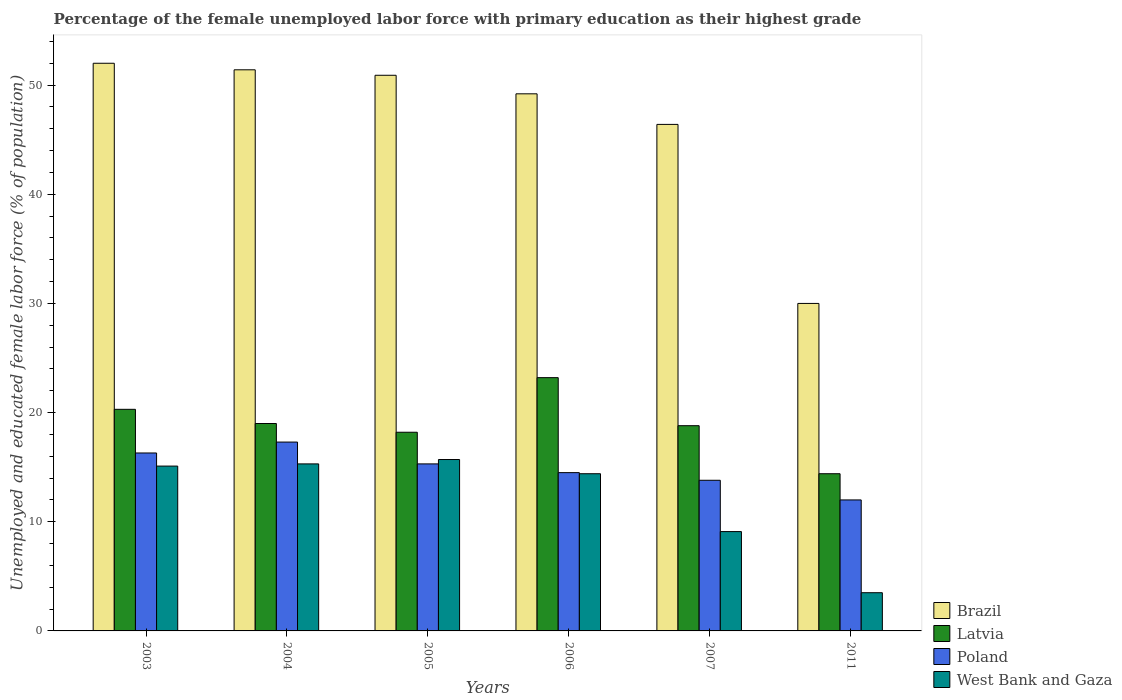How many different coloured bars are there?
Ensure brevity in your answer.  4. How many groups of bars are there?
Offer a very short reply. 6. What is the percentage of the unemployed female labor force with primary education in Latvia in 2004?
Your response must be concise. 19. Across all years, what is the maximum percentage of the unemployed female labor force with primary education in Latvia?
Ensure brevity in your answer.  23.2. What is the total percentage of the unemployed female labor force with primary education in West Bank and Gaza in the graph?
Offer a very short reply. 73.1. What is the difference between the percentage of the unemployed female labor force with primary education in Latvia in 2003 and the percentage of the unemployed female labor force with primary education in Brazil in 2004?
Give a very brief answer. -31.1. What is the average percentage of the unemployed female labor force with primary education in West Bank and Gaza per year?
Provide a succinct answer. 12.18. What is the ratio of the percentage of the unemployed female labor force with primary education in Poland in 2004 to that in 2007?
Your answer should be compact. 1.25. Is the percentage of the unemployed female labor force with primary education in Latvia in 2003 less than that in 2005?
Your response must be concise. No. What is the difference between the highest and the second highest percentage of the unemployed female labor force with primary education in West Bank and Gaza?
Give a very brief answer. 0.4. What is the difference between the highest and the lowest percentage of the unemployed female labor force with primary education in Latvia?
Your answer should be compact. 8.8. In how many years, is the percentage of the unemployed female labor force with primary education in West Bank and Gaza greater than the average percentage of the unemployed female labor force with primary education in West Bank and Gaza taken over all years?
Keep it short and to the point. 4. Is it the case that in every year, the sum of the percentage of the unemployed female labor force with primary education in Latvia and percentage of the unemployed female labor force with primary education in Poland is greater than the sum of percentage of the unemployed female labor force with primary education in West Bank and Gaza and percentage of the unemployed female labor force with primary education in Brazil?
Keep it short and to the point. No. What does the 1st bar from the right in 2004 represents?
Make the answer very short. West Bank and Gaza. How many bars are there?
Make the answer very short. 24. How many years are there in the graph?
Give a very brief answer. 6. What is the difference between two consecutive major ticks on the Y-axis?
Offer a very short reply. 10. Where does the legend appear in the graph?
Give a very brief answer. Bottom right. How are the legend labels stacked?
Provide a short and direct response. Vertical. What is the title of the graph?
Offer a terse response. Percentage of the female unemployed labor force with primary education as their highest grade. Does "Sint Maarten (Dutch part)" appear as one of the legend labels in the graph?
Your answer should be compact. No. What is the label or title of the Y-axis?
Ensure brevity in your answer.  Unemployed and educated female labor force (% of population). What is the Unemployed and educated female labor force (% of population) of Brazil in 2003?
Offer a very short reply. 52. What is the Unemployed and educated female labor force (% of population) in Latvia in 2003?
Give a very brief answer. 20.3. What is the Unemployed and educated female labor force (% of population) of Poland in 2003?
Offer a terse response. 16.3. What is the Unemployed and educated female labor force (% of population) in West Bank and Gaza in 2003?
Offer a very short reply. 15.1. What is the Unemployed and educated female labor force (% of population) in Brazil in 2004?
Provide a short and direct response. 51.4. What is the Unemployed and educated female labor force (% of population) of Poland in 2004?
Give a very brief answer. 17.3. What is the Unemployed and educated female labor force (% of population) in West Bank and Gaza in 2004?
Make the answer very short. 15.3. What is the Unemployed and educated female labor force (% of population) in Brazil in 2005?
Provide a succinct answer. 50.9. What is the Unemployed and educated female labor force (% of population) of Latvia in 2005?
Give a very brief answer. 18.2. What is the Unemployed and educated female labor force (% of population) of Poland in 2005?
Offer a terse response. 15.3. What is the Unemployed and educated female labor force (% of population) of West Bank and Gaza in 2005?
Your answer should be compact. 15.7. What is the Unemployed and educated female labor force (% of population) of Brazil in 2006?
Your response must be concise. 49.2. What is the Unemployed and educated female labor force (% of population) in Latvia in 2006?
Provide a succinct answer. 23.2. What is the Unemployed and educated female labor force (% of population) in West Bank and Gaza in 2006?
Offer a terse response. 14.4. What is the Unemployed and educated female labor force (% of population) in Brazil in 2007?
Provide a short and direct response. 46.4. What is the Unemployed and educated female labor force (% of population) of Latvia in 2007?
Make the answer very short. 18.8. What is the Unemployed and educated female labor force (% of population) of Poland in 2007?
Offer a very short reply. 13.8. What is the Unemployed and educated female labor force (% of population) of West Bank and Gaza in 2007?
Ensure brevity in your answer.  9.1. What is the Unemployed and educated female labor force (% of population) in Brazil in 2011?
Your answer should be very brief. 30. What is the Unemployed and educated female labor force (% of population) in Latvia in 2011?
Give a very brief answer. 14.4. What is the Unemployed and educated female labor force (% of population) in Poland in 2011?
Provide a short and direct response. 12. Across all years, what is the maximum Unemployed and educated female labor force (% of population) of Brazil?
Make the answer very short. 52. Across all years, what is the maximum Unemployed and educated female labor force (% of population) of Latvia?
Your response must be concise. 23.2. Across all years, what is the maximum Unemployed and educated female labor force (% of population) in Poland?
Ensure brevity in your answer.  17.3. Across all years, what is the maximum Unemployed and educated female labor force (% of population) in West Bank and Gaza?
Give a very brief answer. 15.7. Across all years, what is the minimum Unemployed and educated female labor force (% of population) of Brazil?
Offer a terse response. 30. Across all years, what is the minimum Unemployed and educated female labor force (% of population) of Latvia?
Provide a short and direct response. 14.4. What is the total Unemployed and educated female labor force (% of population) of Brazil in the graph?
Offer a terse response. 279.9. What is the total Unemployed and educated female labor force (% of population) in Latvia in the graph?
Make the answer very short. 113.9. What is the total Unemployed and educated female labor force (% of population) of Poland in the graph?
Offer a very short reply. 89.2. What is the total Unemployed and educated female labor force (% of population) of West Bank and Gaza in the graph?
Provide a short and direct response. 73.1. What is the difference between the Unemployed and educated female labor force (% of population) in Brazil in 2003 and that in 2004?
Your answer should be very brief. 0.6. What is the difference between the Unemployed and educated female labor force (% of population) of Brazil in 2003 and that in 2005?
Your response must be concise. 1.1. What is the difference between the Unemployed and educated female labor force (% of population) of Brazil in 2003 and that in 2006?
Provide a short and direct response. 2.8. What is the difference between the Unemployed and educated female labor force (% of population) in Poland in 2003 and that in 2007?
Offer a very short reply. 2.5. What is the difference between the Unemployed and educated female labor force (% of population) of Brazil in 2003 and that in 2011?
Give a very brief answer. 22. What is the difference between the Unemployed and educated female labor force (% of population) in Poland in 2003 and that in 2011?
Ensure brevity in your answer.  4.3. What is the difference between the Unemployed and educated female labor force (% of population) in Brazil in 2004 and that in 2005?
Provide a succinct answer. 0.5. What is the difference between the Unemployed and educated female labor force (% of population) in Latvia in 2004 and that in 2005?
Your answer should be very brief. 0.8. What is the difference between the Unemployed and educated female labor force (% of population) of Latvia in 2004 and that in 2006?
Your response must be concise. -4.2. What is the difference between the Unemployed and educated female labor force (% of population) of Poland in 2004 and that in 2006?
Provide a succinct answer. 2.8. What is the difference between the Unemployed and educated female labor force (% of population) of West Bank and Gaza in 2004 and that in 2006?
Your answer should be very brief. 0.9. What is the difference between the Unemployed and educated female labor force (% of population) in Brazil in 2004 and that in 2007?
Provide a short and direct response. 5. What is the difference between the Unemployed and educated female labor force (% of population) in Poland in 2004 and that in 2007?
Give a very brief answer. 3.5. What is the difference between the Unemployed and educated female labor force (% of population) of West Bank and Gaza in 2004 and that in 2007?
Give a very brief answer. 6.2. What is the difference between the Unemployed and educated female labor force (% of population) in Brazil in 2004 and that in 2011?
Ensure brevity in your answer.  21.4. What is the difference between the Unemployed and educated female labor force (% of population) of Latvia in 2004 and that in 2011?
Your answer should be compact. 4.6. What is the difference between the Unemployed and educated female labor force (% of population) of Poland in 2004 and that in 2011?
Make the answer very short. 5.3. What is the difference between the Unemployed and educated female labor force (% of population) of West Bank and Gaza in 2004 and that in 2011?
Ensure brevity in your answer.  11.8. What is the difference between the Unemployed and educated female labor force (% of population) of Poland in 2005 and that in 2006?
Provide a succinct answer. 0.8. What is the difference between the Unemployed and educated female labor force (% of population) of Latvia in 2005 and that in 2007?
Your answer should be very brief. -0.6. What is the difference between the Unemployed and educated female labor force (% of population) of Brazil in 2005 and that in 2011?
Your response must be concise. 20.9. What is the difference between the Unemployed and educated female labor force (% of population) in West Bank and Gaza in 2005 and that in 2011?
Provide a short and direct response. 12.2. What is the difference between the Unemployed and educated female labor force (% of population) of Brazil in 2006 and that in 2007?
Offer a very short reply. 2.8. What is the difference between the Unemployed and educated female labor force (% of population) of West Bank and Gaza in 2006 and that in 2007?
Provide a short and direct response. 5.3. What is the difference between the Unemployed and educated female labor force (% of population) of Poland in 2006 and that in 2011?
Offer a very short reply. 2.5. What is the difference between the Unemployed and educated female labor force (% of population) of Latvia in 2007 and that in 2011?
Provide a short and direct response. 4.4. What is the difference between the Unemployed and educated female labor force (% of population) of Poland in 2007 and that in 2011?
Provide a short and direct response. 1.8. What is the difference between the Unemployed and educated female labor force (% of population) in Brazil in 2003 and the Unemployed and educated female labor force (% of population) in Poland in 2004?
Your answer should be compact. 34.7. What is the difference between the Unemployed and educated female labor force (% of population) in Brazil in 2003 and the Unemployed and educated female labor force (% of population) in West Bank and Gaza in 2004?
Give a very brief answer. 36.7. What is the difference between the Unemployed and educated female labor force (% of population) of Latvia in 2003 and the Unemployed and educated female labor force (% of population) of Poland in 2004?
Provide a short and direct response. 3. What is the difference between the Unemployed and educated female labor force (% of population) of Latvia in 2003 and the Unemployed and educated female labor force (% of population) of West Bank and Gaza in 2004?
Give a very brief answer. 5. What is the difference between the Unemployed and educated female labor force (% of population) in Brazil in 2003 and the Unemployed and educated female labor force (% of population) in Latvia in 2005?
Give a very brief answer. 33.8. What is the difference between the Unemployed and educated female labor force (% of population) of Brazil in 2003 and the Unemployed and educated female labor force (% of population) of Poland in 2005?
Keep it short and to the point. 36.7. What is the difference between the Unemployed and educated female labor force (% of population) of Brazil in 2003 and the Unemployed and educated female labor force (% of population) of West Bank and Gaza in 2005?
Your answer should be very brief. 36.3. What is the difference between the Unemployed and educated female labor force (% of population) of Brazil in 2003 and the Unemployed and educated female labor force (% of population) of Latvia in 2006?
Provide a short and direct response. 28.8. What is the difference between the Unemployed and educated female labor force (% of population) in Brazil in 2003 and the Unemployed and educated female labor force (% of population) in Poland in 2006?
Your answer should be compact. 37.5. What is the difference between the Unemployed and educated female labor force (% of population) of Brazil in 2003 and the Unemployed and educated female labor force (% of population) of West Bank and Gaza in 2006?
Your answer should be very brief. 37.6. What is the difference between the Unemployed and educated female labor force (% of population) of Latvia in 2003 and the Unemployed and educated female labor force (% of population) of West Bank and Gaza in 2006?
Provide a succinct answer. 5.9. What is the difference between the Unemployed and educated female labor force (% of population) of Poland in 2003 and the Unemployed and educated female labor force (% of population) of West Bank and Gaza in 2006?
Offer a very short reply. 1.9. What is the difference between the Unemployed and educated female labor force (% of population) in Brazil in 2003 and the Unemployed and educated female labor force (% of population) in Latvia in 2007?
Give a very brief answer. 33.2. What is the difference between the Unemployed and educated female labor force (% of population) of Brazil in 2003 and the Unemployed and educated female labor force (% of population) of Poland in 2007?
Your answer should be very brief. 38.2. What is the difference between the Unemployed and educated female labor force (% of population) of Brazil in 2003 and the Unemployed and educated female labor force (% of population) of West Bank and Gaza in 2007?
Your answer should be compact. 42.9. What is the difference between the Unemployed and educated female labor force (% of population) of Latvia in 2003 and the Unemployed and educated female labor force (% of population) of Poland in 2007?
Your answer should be compact. 6.5. What is the difference between the Unemployed and educated female labor force (% of population) of Poland in 2003 and the Unemployed and educated female labor force (% of population) of West Bank and Gaza in 2007?
Offer a very short reply. 7.2. What is the difference between the Unemployed and educated female labor force (% of population) of Brazil in 2003 and the Unemployed and educated female labor force (% of population) of Latvia in 2011?
Your answer should be very brief. 37.6. What is the difference between the Unemployed and educated female labor force (% of population) of Brazil in 2003 and the Unemployed and educated female labor force (% of population) of West Bank and Gaza in 2011?
Keep it short and to the point. 48.5. What is the difference between the Unemployed and educated female labor force (% of population) in Latvia in 2003 and the Unemployed and educated female labor force (% of population) in West Bank and Gaza in 2011?
Provide a succinct answer. 16.8. What is the difference between the Unemployed and educated female labor force (% of population) of Poland in 2003 and the Unemployed and educated female labor force (% of population) of West Bank and Gaza in 2011?
Your answer should be compact. 12.8. What is the difference between the Unemployed and educated female labor force (% of population) in Brazil in 2004 and the Unemployed and educated female labor force (% of population) in Latvia in 2005?
Keep it short and to the point. 33.2. What is the difference between the Unemployed and educated female labor force (% of population) of Brazil in 2004 and the Unemployed and educated female labor force (% of population) of Poland in 2005?
Ensure brevity in your answer.  36.1. What is the difference between the Unemployed and educated female labor force (% of population) in Brazil in 2004 and the Unemployed and educated female labor force (% of population) in West Bank and Gaza in 2005?
Give a very brief answer. 35.7. What is the difference between the Unemployed and educated female labor force (% of population) in Latvia in 2004 and the Unemployed and educated female labor force (% of population) in Poland in 2005?
Provide a succinct answer. 3.7. What is the difference between the Unemployed and educated female labor force (% of population) of Poland in 2004 and the Unemployed and educated female labor force (% of population) of West Bank and Gaza in 2005?
Keep it short and to the point. 1.6. What is the difference between the Unemployed and educated female labor force (% of population) of Brazil in 2004 and the Unemployed and educated female labor force (% of population) of Latvia in 2006?
Keep it short and to the point. 28.2. What is the difference between the Unemployed and educated female labor force (% of population) in Brazil in 2004 and the Unemployed and educated female labor force (% of population) in Poland in 2006?
Ensure brevity in your answer.  36.9. What is the difference between the Unemployed and educated female labor force (% of population) in Brazil in 2004 and the Unemployed and educated female labor force (% of population) in West Bank and Gaza in 2006?
Your answer should be compact. 37. What is the difference between the Unemployed and educated female labor force (% of population) of Latvia in 2004 and the Unemployed and educated female labor force (% of population) of Poland in 2006?
Your answer should be very brief. 4.5. What is the difference between the Unemployed and educated female labor force (% of population) in Brazil in 2004 and the Unemployed and educated female labor force (% of population) in Latvia in 2007?
Give a very brief answer. 32.6. What is the difference between the Unemployed and educated female labor force (% of population) of Brazil in 2004 and the Unemployed and educated female labor force (% of population) of Poland in 2007?
Your answer should be compact. 37.6. What is the difference between the Unemployed and educated female labor force (% of population) of Brazil in 2004 and the Unemployed and educated female labor force (% of population) of West Bank and Gaza in 2007?
Keep it short and to the point. 42.3. What is the difference between the Unemployed and educated female labor force (% of population) in Latvia in 2004 and the Unemployed and educated female labor force (% of population) in Poland in 2007?
Keep it short and to the point. 5.2. What is the difference between the Unemployed and educated female labor force (% of population) in Poland in 2004 and the Unemployed and educated female labor force (% of population) in West Bank and Gaza in 2007?
Your answer should be very brief. 8.2. What is the difference between the Unemployed and educated female labor force (% of population) in Brazil in 2004 and the Unemployed and educated female labor force (% of population) in Poland in 2011?
Keep it short and to the point. 39.4. What is the difference between the Unemployed and educated female labor force (% of population) of Brazil in 2004 and the Unemployed and educated female labor force (% of population) of West Bank and Gaza in 2011?
Ensure brevity in your answer.  47.9. What is the difference between the Unemployed and educated female labor force (% of population) in Latvia in 2004 and the Unemployed and educated female labor force (% of population) in Poland in 2011?
Provide a short and direct response. 7. What is the difference between the Unemployed and educated female labor force (% of population) in Poland in 2004 and the Unemployed and educated female labor force (% of population) in West Bank and Gaza in 2011?
Ensure brevity in your answer.  13.8. What is the difference between the Unemployed and educated female labor force (% of population) of Brazil in 2005 and the Unemployed and educated female labor force (% of population) of Latvia in 2006?
Your answer should be compact. 27.7. What is the difference between the Unemployed and educated female labor force (% of population) of Brazil in 2005 and the Unemployed and educated female labor force (% of population) of Poland in 2006?
Your answer should be compact. 36.4. What is the difference between the Unemployed and educated female labor force (% of population) of Brazil in 2005 and the Unemployed and educated female labor force (% of population) of West Bank and Gaza in 2006?
Your answer should be compact. 36.5. What is the difference between the Unemployed and educated female labor force (% of population) of Latvia in 2005 and the Unemployed and educated female labor force (% of population) of Poland in 2006?
Offer a very short reply. 3.7. What is the difference between the Unemployed and educated female labor force (% of population) of Poland in 2005 and the Unemployed and educated female labor force (% of population) of West Bank and Gaza in 2006?
Keep it short and to the point. 0.9. What is the difference between the Unemployed and educated female labor force (% of population) in Brazil in 2005 and the Unemployed and educated female labor force (% of population) in Latvia in 2007?
Offer a terse response. 32.1. What is the difference between the Unemployed and educated female labor force (% of population) of Brazil in 2005 and the Unemployed and educated female labor force (% of population) of Poland in 2007?
Your answer should be compact. 37.1. What is the difference between the Unemployed and educated female labor force (% of population) of Brazil in 2005 and the Unemployed and educated female labor force (% of population) of West Bank and Gaza in 2007?
Give a very brief answer. 41.8. What is the difference between the Unemployed and educated female labor force (% of population) of Latvia in 2005 and the Unemployed and educated female labor force (% of population) of Poland in 2007?
Your answer should be compact. 4.4. What is the difference between the Unemployed and educated female labor force (% of population) in Poland in 2005 and the Unemployed and educated female labor force (% of population) in West Bank and Gaza in 2007?
Your answer should be very brief. 6.2. What is the difference between the Unemployed and educated female labor force (% of population) of Brazil in 2005 and the Unemployed and educated female labor force (% of population) of Latvia in 2011?
Make the answer very short. 36.5. What is the difference between the Unemployed and educated female labor force (% of population) of Brazil in 2005 and the Unemployed and educated female labor force (% of population) of Poland in 2011?
Provide a succinct answer. 38.9. What is the difference between the Unemployed and educated female labor force (% of population) in Brazil in 2005 and the Unemployed and educated female labor force (% of population) in West Bank and Gaza in 2011?
Ensure brevity in your answer.  47.4. What is the difference between the Unemployed and educated female labor force (% of population) of Latvia in 2005 and the Unemployed and educated female labor force (% of population) of Poland in 2011?
Your answer should be very brief. 6.2. What is the difference between the Unemployed and educated female labor force (% of population) of Latvia in 2005 and the Unemployed and educated female labor force (% of population) of West Bank and Gaza in 2011?
Provide a short and direct response. 14.7. What is the difference between the Unemployed and educated female labor force (% of population) in Brazil in 2006 and the Unemployed and educated female labor force (% of population) in Latvia in 2007?
Your response must be concise. 30.4. What is the difference between the Unemployed and educated female labor force (% of population) in Brazil in 2006 and the Unemployed and educated female labor force (% of population) in Poland in 2007?
Provide a succinct answer. 35.4. What is the difference between the Unemployed and educated female labor force (% of population) in Brazil in 2006 and the Unemployed and educated female labor force (% of population) in West Bank and Gaza in 2007?
Your answer should be compact. 40.1. What is the difference between the Unemployed and educated female labor force (% of population) in Latvia in 2006 and the Unemployed and educated female labor force (% of population) in Poland in 2007?
Provide a short and direct response. 9.4. What is the difference between the Unemployed and educated female labor force (% of population) in Brazil in 2006 and the Unemployed and educated female labor force (% of population) in Latvia in 2011?
Keep it short and to the point. 34.8. What is the difference between the Unemployed and educated female labor force (% of population) of Brazil in 2006 and the Unemployed and educated female labor force (% of population) of Poland in 2011?
Provide a succinct answer. 37.2. What is the difference between the Unemployed and educated female labor force (% of population) of Brazil in 2006 and the Unemployed and educated female labor force (% of population) of West Bank and Gaza in 2011?
Give a very brief answer. 45.7. What is the difference between the Unemployed and educated female labor force (% of population) of Brazil in 2007 and the Unemployed and educated female labor force (% of population) of Poland in 2011?
Offer a very short reply. 34.4. What is the difference between the Unemployed and educated female labor force (% of population) in Brazil in 2007 and the Unemployed and educated female labor force (% of population) in West Bank and Gaza in 2011?
Your answer should be compact. 42.9. What is the difference between the Unemployed and educated female labor force (% of population) of Latvia in 2007 and the Unemployed and educated female labor force (% of population) of Poland in 2011?
Provide a succinct answer. 6.8. What is the difference between the Unemployed and educated female labor force (% of population) of Poland in 2007 and the Unemployed and educated female labor force (% of population) of West Bank and Gaza in 2011?
Your response must be concise. 10.3. What is the average Unemployed and educated female labor force (% of population) in Brazil per year?
Ensure brevity in your answer.  46.65. What is the average Unemployed and educated female labor force (% of population) in Latvia per year?
Provide a short and direct response. 18.98. What is the average Unemployed and educated female labor force (% of population) in Poland per year?
Make the answer very short. 14.87. What is the average Unemployed and educated female labor force (% of population) in West Bank and Gaza per year?
Provide a succinct answer. 12.18. In the year 2003, what is the difference between the Unemployed and educated female labor force (% of population) of Brazil and Unemployed and educated female labor force (% of population) of Latvia?
Ensure brevity in your answer.  31.7. In the year 2003, what is the difference between the Unemployed and educated female labor force (% of population) of Brazil and Unemployed and educated female labor force (% of population) of Poland?
Your response must be concise. 35.7. In the year 2003, what is the difference between the Unemployed and educated female labor force (% of population) of Brazil and Unemployed and educated female labor force (% of population) of West Bank and Gaza?
Give a very brief answer. 36.9. In the year 2003, what is the difference between the Unemployed and educated female labor force (% of population) of Poland and Unemployed and educated female labor force (% of population) of West Bank and Gaza?
Provide a succinct answer. 1.2. In the year 2004, what is the difference between the Unemployed and educated female labor force (% of population) in Brazil and Unemployed and educated female labor force (% of population) in Latvia?
Your answer should be compact. 32.4. In the year 2004, what is the difference between the Unemployed and educated female labor force (% of population) of Brazil and Unemployed and educated female labor force (% of population) of Poland?
Ensure brevity in your answer.  34.1. In the year 2004, what is the difference between the Unemployed and educated female labor force (% of population) of Brazil and Unemployed and educated female labor force (% of population) of West Bank and Gaza?
Your answer should be very brief. 36.1. In the year 2004, what is the difference between the Unemployed and educated female labor force (% of population) of Latvia and Unemployed and educated female labor force (% of population) of Poland?
Provide a succinct answer. 1.7. In the year 2004, what is the difference between the Unemployed and educated female labor force (% of population) in Latvia and Unemployed and educated female labor force (% of population) in West Bank and Gaza?
Your response must be concise. 3.7. In the year 2004, what is the difference between the Unemployed and educated female labor force (% of population) of Poland and Unemployed and educated female labor force (% of population) of West Bank and Gaza?
Your response must be concise. 2. In the year 2005, what is the difference between the Unemployed and educated female labor force (% of population) of Brazil and Unemployed and educated female labor force (% of population) of Latvia?
Provide a short and direct response. 32.7. In the year 2005, what is the difference between the Unemployed and educated female labor force (% of population) in Brazil and Unemployed and educated female labor force (% of population) in Poland?
Offer a very short reply. 35.6. In the year 2005, what is the difference between the Unemployed and educated female labor force (% of population) of Brazil and Unemployed and educated female labor force (% of population) of West Bank and Gaza?
Give a very brief answer. 35.2. In the year 2005, what is the difference between the Unemployed and educated female labor force (% of population) in Latvia and Unemployed and educated female labor force (% of population) in Poland?
Provide a succinct answer. 2.9. In the year 2006, what is the difference between the Unemployed and educated female labor force (% of population) of Brazil and Unemployed and educated female labor force (% of population) of Poland?
Offer a very short reply. 34.7. In the year 2006, what is the difference between the Unemployed and educated female labor force (% of population) of Brazil and Unemployed and educated female labor force (% of population) of West Bank and Gaza?
Give a very brief answer. 34.8. In the year 2006, what is the difference between the Unemployed and educated female labor force (% of population) in Latvia and Unemployed and educated female labor force (% of population) in Poland?
Your answer should be very brief. 8.7. In the year 2006, what is the difference between the Unemployed and educated female labor force (% of population) in Latvia and Unemployed and educated female labor force (% of population) in West Bank and Gaza?
Keep it short and to the point. 8.8. In the year 2007, what is the difference between the Unemployed and educated female labor force (% of population) in Brazil and Unemployed and educated female labor force (% of population) in Latvia?
Your response must be concise. 27.6. In the year 2007, what is the difference between the Unemployed and educated female labor force (% of population) in Brazil and Unemployed and educated female labor force (% of population) in Poland?
Make the answer very short. 32.6. In the year 2007, what is the difference between the Unemployed and educated female labor force (% of population) of Brazil and Unemployed and educated female labor force (% of population) of West Bank and Gaza?
Offer a terse response. 37.3. In the year 2007, what is the difference between the Unemployed and educated female labor force (% of population) of Latvia and Unemployed and educated female labor force (% of population) of Poland?
Offer a very short reply. 5. In the year 2007, what is the difference between the Unemployed and educated female labor force (% of population) of Latvia and Unemployed and educated female labor force (% of population) of West Bank and Gaza?
Provide a succinct answer. 9.7. In the year 2007, what is the difference between the Unemployed and educated female labor force (% of population) of Poland and Unemployed and educated female labor force (% of population) of West Bank and Gaza?
Your answer should be compact. 4.7. In the year 2011, what is the difference between the Unemployed and educated female labor force (% of population) in Brazil and Unemployed and educated female labor force (% of population) in Poland?
Offer a very short reply. 18. In the year 2011, what is the difference between the Unemployed and educated female labor force (% of population) of Latvia and Unemployed and educated female labor force (% of population) of West Bank and Gaza?
Your response must be concise. 10.9. In the year 2011, what is the difference between the Unemployed and educated female labor force (% of population) in Poland and Unemployed and educated female labor force (% of population) in West Bank and Gaza?
Your answer should be compact. 8.5. What is the ratio of the Unemployed and educated female labor force (% of population) of Brazil in 2003 to that in 2004?
Offer a terse response. 1.01. What is the ratio of the Unemployed and educated female labor force (% of population) of Latvia in 2003 to that in 2004?
Keep it short and to the point. 1.07. What is the ratio of the Unemployed and educated female labor force (% of population) of Poland in 2003 to that in 2004?
Your response must be concise. 0.94. What is the ratio of the Unemployed and educated female labor force (% of population) in West Bank and Gaza in 2003 to that in 2004?
Your response must be concise. 0.99. What is the ratio of the Unemployed and educated female labor force (% of population) of Brazil in 2003 to that in 2005?
Give a very brief answer. 1.02. What is the ratio of the Unemployed and educated female labor force (% of population) in Latvia in 2003 to that in 2005?
Your answer should be compact. 1.12. What is the ratio of the Unemployed and educated female labor force (% of population) in Poland in 2003 to that in 2005?
Offer a very short reply. 1.07. What is the ratio of the Unemployed and educated female labor force (% of population) of West Bank and Gaza in 2003 to that in 2005?
Your answer should be compact. 0.96. What is the ratio of the Unemployed and educated female labor force (% of population) in Brazil in 2003 to that in 2006?
Your answer should be very brief. 1.06. What is the ratio of the Unemployed and educated female labor force (% of population) of Poland in 2003 to that in 2006?
Offer a very short reply. 1.12. What is the ratio of the Unemployed and educated female labor force (% of population) in West Bank and Gaza in 2003 to that in 2006?
Your answer should be compact. 1.05. What is the ratio of the Unemployed and educated female labor force (% of population) in Brazil in 2003 to that in 2007?
Provide a short and direct response. 1.12. What is the ratio of the Unemployed and educated female labor force (% of population) in Latvia in 2003 to that in 2007?
Give a very brief answer. 1.08. What is the ratio of the Unemployed and educated female labor force (% of population) in Poland in 2003 to that in 2007?
Provide a succinct answer. 1.18. What is the ratio of the Unemployed and educated female labor force (% of population) of West Bank and Gaza in 2003 to that in 2007?
Offer a very short reply. 1.66. What is the ratio of the Unemployed and educated female labor force (% of population) of Brazil in 2003 to that in 2011?
Provide a succinct answer. 1.73. What is the ratio of the Unemployed and educated female labor force (% of population) of Latvia in 2003 to that in 2011?
Make the answer very short. 1.41. What is the ratio of the Unemployed and educated female labor force (% of population) of Poland in 2003 to that in 2011?
Ensure brevity in your answer.  1.36. What is the ratio of the Unemployed and educated female labor force (% of population) in West Bank and Gaza in 2003 to that in 2011?
Offer a very short reply. 4.31. What is the ratio of the Unemployed and educated female labor force (% of population) in Brazil in 2004 to that in 2005?
Your response must be concise. 1.01. What is the ratio of the Unemployed and educated female labor force (% of population) in Latvia in 2004 to that in 2005?
Provide a short and direct response. 1.04. What is the ratio of the Unemployed and educated female labor force (% of population) in Poland in 2004 to that in 2005?
Offer a very short reply. 1.13. What is the ratio of the Unemployed and educated female labor force (% of population) of West Bank and Gaza in 2004 to that in 2005?
Provide a short and direct response. 0.97. What is the ratio of the Unemployed and educated female labor force (% of population) in Brazil in 2004 to that in 2006?
Give a very brief answer. 1.04. What is the ratio of the Unemployed and educated female labor force (% of population) of Latvia in 2004 to that in 2006?
Keep it short and to the point. 0.82. What is the ratio of the Unemployed and educated female labor force (% of population) in Poland in 2004 to that in 2006?
Your response must be concise. 1.19. What is the ratio of the Unemployed and educated female labor force (% of population) in Brazil in 2004 to that in 2007?
Make the answer very short. 1.11. What is the ratio of the Unemployed and educated female labor force (% of population) in Latvia in 2004 to that in 2007?
Provide a short and direct response. 1.01. What is the ratio of the Unemployed and educated female labor force (% of population) of Poland in 2004 to that in 2007?
Make the answer very short. 1.25. What is the ratio of the Unemployed and educated female labor force (% of population) of West Bank and Gaza in 2004 to that in 2007?
Ensure brevity in your answer.  1.68. What is the ratio of the Unemployed and educated female labor force (% of population) in Brazil in 2004 to that in 2011?
Offer a terse response. 1.71. What is the ratio of the Unemployed and educated female labor force (% of population) of Latvia in 2004 to that in 2011?
Give a very brief answer. 1.32. What is the ratio of the Unemployed and educated female labor force (% of population) in Poland in 2004 to that in 2011?
Offer a very short reply. 1.44. What is the ratio of the Unemployed and educated female labor force (% of population) of West Bank and Gaza in 2004 to that in 2011?
Ensure brevity in your answer.  4.37. What is the ratio of the Unemployed and educated female labor force (% of population) of Brazil in 2005 to that in 2006?
Your answer should be compact. 1.03. What is the ratio of the Unemployed and educated female labor force (% of population) in Latvia in 2005 to that in 2006?
Your response must be concise. 0.78. What is the ratio of the Unemployed and educated female labor force (% of population) of Poland in 2005 to that in 2006?
Provide a short and direct response. 1.06. What is the ratio of the Unemployed and educated female labor force (% of population) in West Bank and Gaza in 2005 to that in 2006?
Give a very brief answer. 1.09. What is the ratio of the Unemployed and educated female labor force (% of population) in Brazil in 2005 to that in 2007?
Provide a succinct answer. 1.1. What is the ratio of the Unemployed and educated female labor force (% of population) in Latvia in 2005 to that in 2007?
Ensure brevity in your answer.  0.97. What is the ratio of the Unemployed and educated female labor force (% of population) of Poland in 2005 to that in 2007?
Offer a very short reply. 1.11. What is the ratio of the Unemployed and educated female labor force (% of population) in West Bank and Gaza in 2005 to that in 2007?
Your answer should be very brief. 1.73. What is the ratio of the Unemployed and educated female labor force (% of population) of Brazil in 2005 to that in 2011?
Your response must be concise. 1.7. What is the ratio of the Unemployed and educated female labor force (% of population) of Latvia in 2005 to that in 2011?
Your answer should be very brief. 1.26. What is the ratio of the Unemployed and educated female labor force (% of population) in Poland in 2005 to that in 2011?
Provide a succinct answer. 1.27. What is the ratio of the Unemployed and educated female labor force (% of population) of West Bank and Gaza in 2005 to that in 2011?
Provide a short and direct response. 4.49. What is the ratio of the Unemployed and educated female labor force (% of population) of Brazil in 2006 to that in 2007?
Give a very brief answer. 1.06. What is the ratio of the Unemployed and educated female labor force (% of population) of Latvia in 2006 to that in 2007?
Give a very brief answer. 1.23. What is the ratio of the Unemployed and educated female labor force (% of population) of Poland in 2006 to that in 2007?
Offer a terse response. 1.05. What is the ratio of the Unemployed and educated female labor force (% of population) in West Bank and Gaza in 2006 to that in 2007?
Give a very brief answer. 1.58. What is the ratio of the Unemployed and educated female labor force (% of population) in Brazil in 2006 to that in 2011?
Offer a terse response. 1.64. What is the ratio of the Unemployed and educated female labor force (% of population) in Latvia in 2006 to that in 2011?
Your answer should be very brief. 1.61. What is the ratio of the Unemployed and educated female labor force (% of population) in Poland in 2006 to that in 2011?
Provide a succinct answer. 1.21. What is the ratio of the Unemployed and educated female labor force (% of population) in West Bank and Gaza in 2006 to that in 2011?
Your response must be concise. 4.11. What is the ratio of the Unemployed and educated female labor force (% of population) of Brazil in 2007 to that in 2011?
Provide a short and direct response. 1.55. What is the ratio of the Unemployed and educated female labor force (% of population) in Latvia in 2007 to that in 2011?
Provide a succinct answer. 1.31. What is the ratio of the Unemployed and educated female labor force (% of population) of Poland in 2007 to that in 2011?
Make the answer very short. 1.15. What is the ratio of the Unemployed and educated female labor force (% of population) of West Bank and Gaza in 2007 to that in 2011?
Provide a short and direct response. 2.6. What is the difference between the highest and the second highest Unemployed and educated female labor force (% of population) of Brazil?
Your answer should be very brief. 0.6. What is the difference between the highest and the second highest Unemployed and educated female labor force (% of population) of Latvia?
Give a very brief answer. 2.9. What is the difference between the highest and the second highest Unemployed and educated female labor force (% of population) in West Bank and Gaza?
Your answer should be compact. 0.4. What is the difference between the highest and the lowest Unemployed and educated female labor force (% of population) in Latvia?
Provide a short and direct response. 8.8. What is the difference between the highest and the lowest Unemployed and educated female labor force (% of population) in Poland?
Your answer should be very brief. 5.3. 